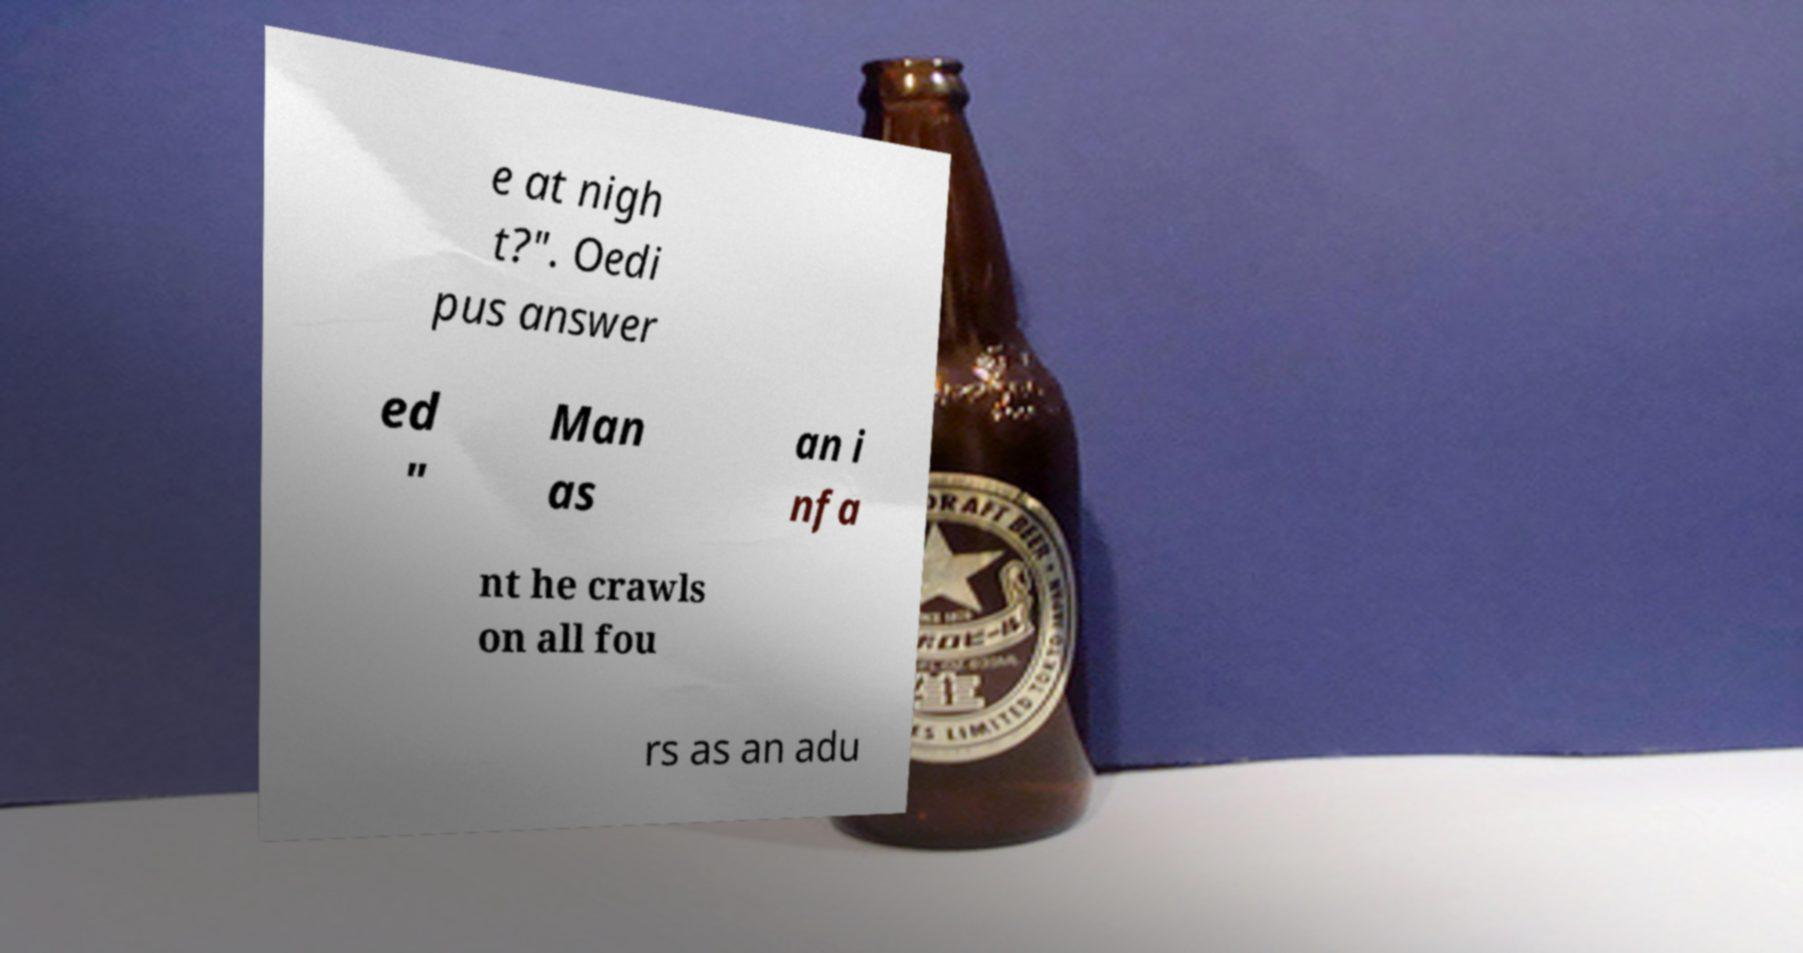For documentation purposes, I need the text within this image transcribed. Could you provide that? e at nigh t?". Oedi pus answer ed " Man as an i nfa nt he crawls on all fou rs as an adu 